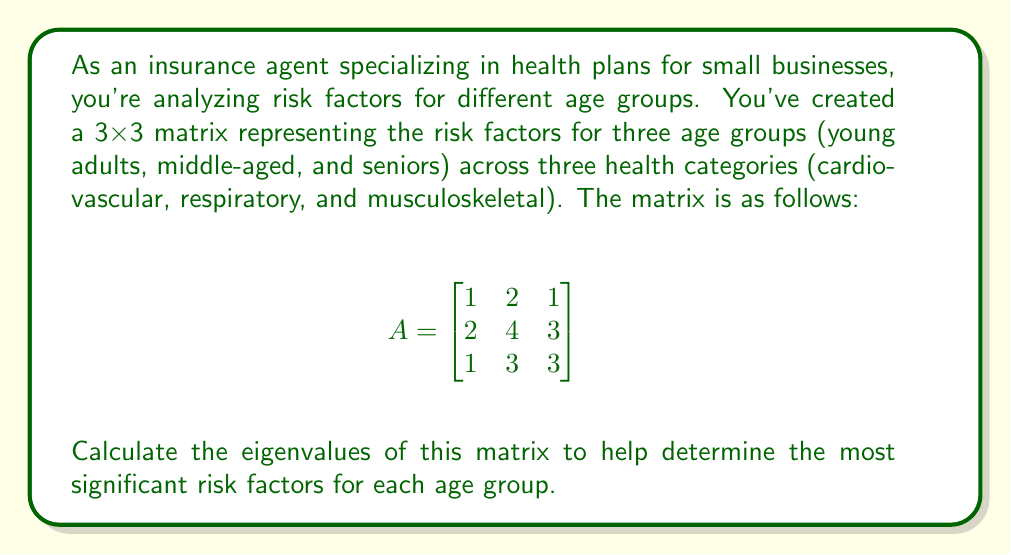Teach me how to tackle this problem. To find the eigenvalues of matrix A, we need to solve the characteristic equation:

$$det(A - \lambda I) = 0$$

Where $\lambda$ represents the eigenvalues and $I$ is the 3x3 identity matrix.

Step 1: Subtract $\lambda I$ from A:

$$A - \lambda I = \begin{bmatrix}
1-\lambda & 2 & 1 \\
2 & 4-\lambda & 3 \\
1 & 3 & 3-\lambda
\end{bmatrix}$$

Step 2: Calculate the determinant:

$$det(A - \lambda I) = (1-\lambda)[(4-\lambda)(3-\lambda) - 9] - 2[2(3-\lambda) - 3] + 1[6 - 2(4-\lambda)]$$

Step 3: Expand the determinant:

$$(1-\lambda)(12-7\lambda+\lambda^2) - 2(6-2\lambda) + (6-8+2\lambda)$$
$$12-7\lambda+\lambda^2 - 12\lambda+7\lambda^2-\lambda^3 - 12+4\lambda + 6-8+2\lambda$$
$$-\lambda^3+8\lambda^2-13\lambda-2 = 0$$

Step 4: Solve the cubic equation. This can be done using the cubic formula or factoring. In this case, we can factor:

$$-(\lambda-2)(\lambda^2-6\lambda+1) = 0$$

Step 5: Solve the resulting equations:

$$\lambda - 2 = 0 \quad \text{or} \quad \lambda^2-6\lambda+1 = 0$$

From the first equation: $\lambda_1 = 2$

For the quadratic equation, use the quadratic formula:

$$\lambda = \frac{6 \pm \sqrt{36-4}}{2} = \frac{6 \pm \sqrt{32}}{2} = \frac{6 \pm 4\sqrt{2}}{2}$$

Therefore, $\lambda_2 = 3 + \sqrt{2}$ and $\lambda_3 = 3 - \sqrt{2}$
Answer: The eigenvalues of the matrix are:
$\lambda_1 = 2$
$\lambda_2 = 3 + \sqrt{2}$
$\lambda_3 = 3 - \sqrt{2}$ 